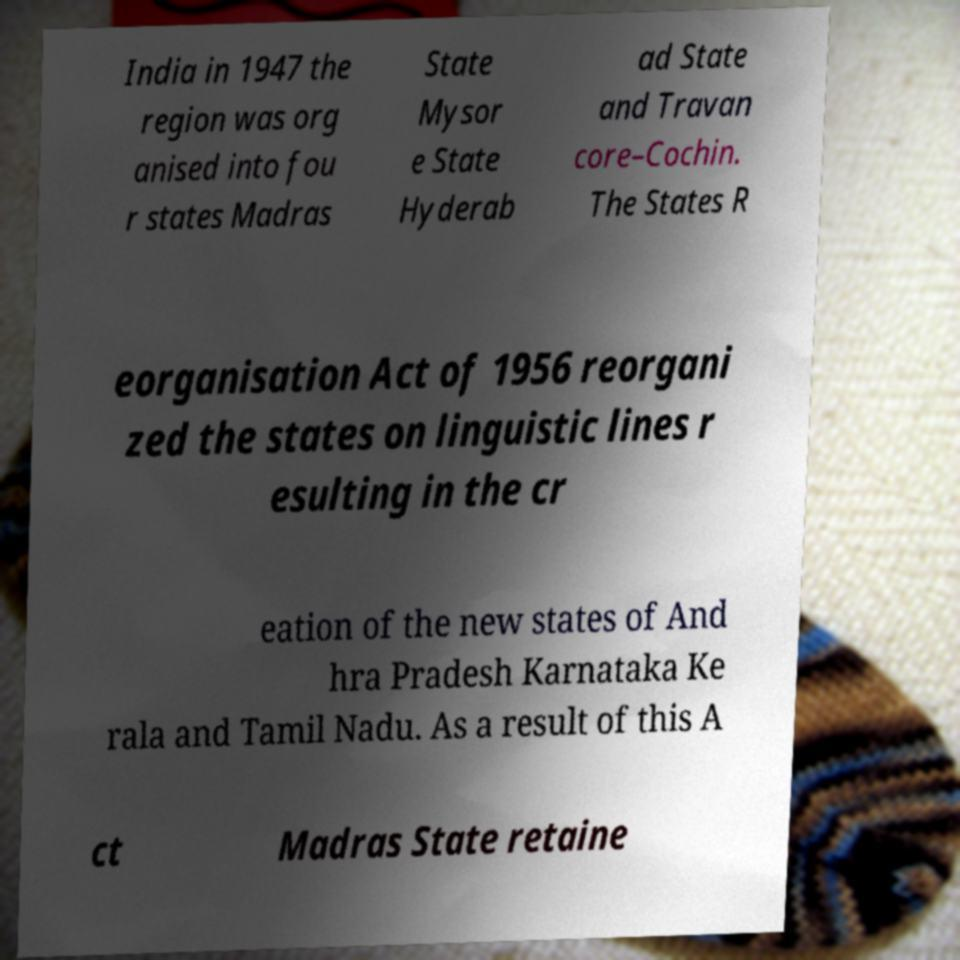I need the written content from this picture converted into text. Can you do that? India in 1947 the region was org anised into fou r states Madras State Mysor e State Hyderab ad State and Travan core–Cochin. The States R eorganisation Act of 1956 reorgani zed the states on linguistic lines r esulting in the cr eation of the new states of And hra Pradesh Karnataka Ke rala and Tamil Nadu. As a result of this A ct Madras State retaine 